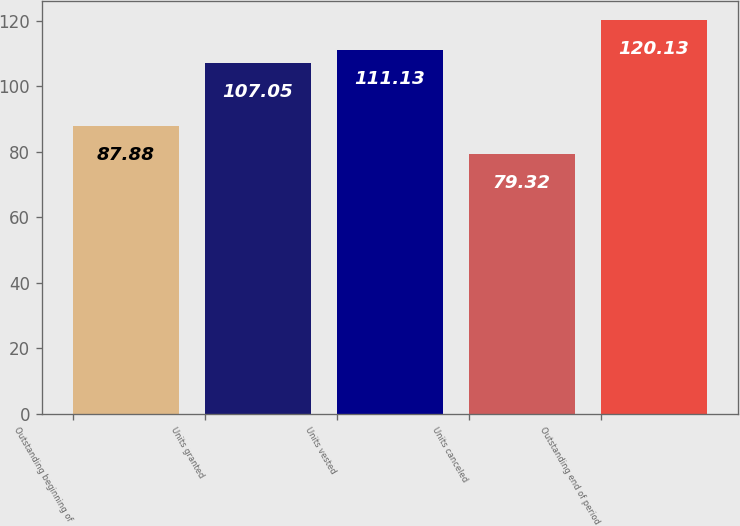Convert chart to OTSL. <chart><loc_0><loc_0><loc_500><loc_500><bar_chart><fcel>Outstanding beginning of<fcel>Units granted<fcel>Units vested<fcel>Units canceled<fcel>Outstanding end of period<nl><fcel>87.88<fcel>107.05<fcel>111.13<fcel>79.32<fcel>120.13<nl></chart> 